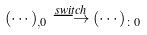<formula> <loc_0><loc_0><loc_500><loc_500>( \cdots ) _ { , 0 } \stackrel { s w i t c h } { \longrightarrow } ( \cdots ) _ { \colon 0 }</formula> 